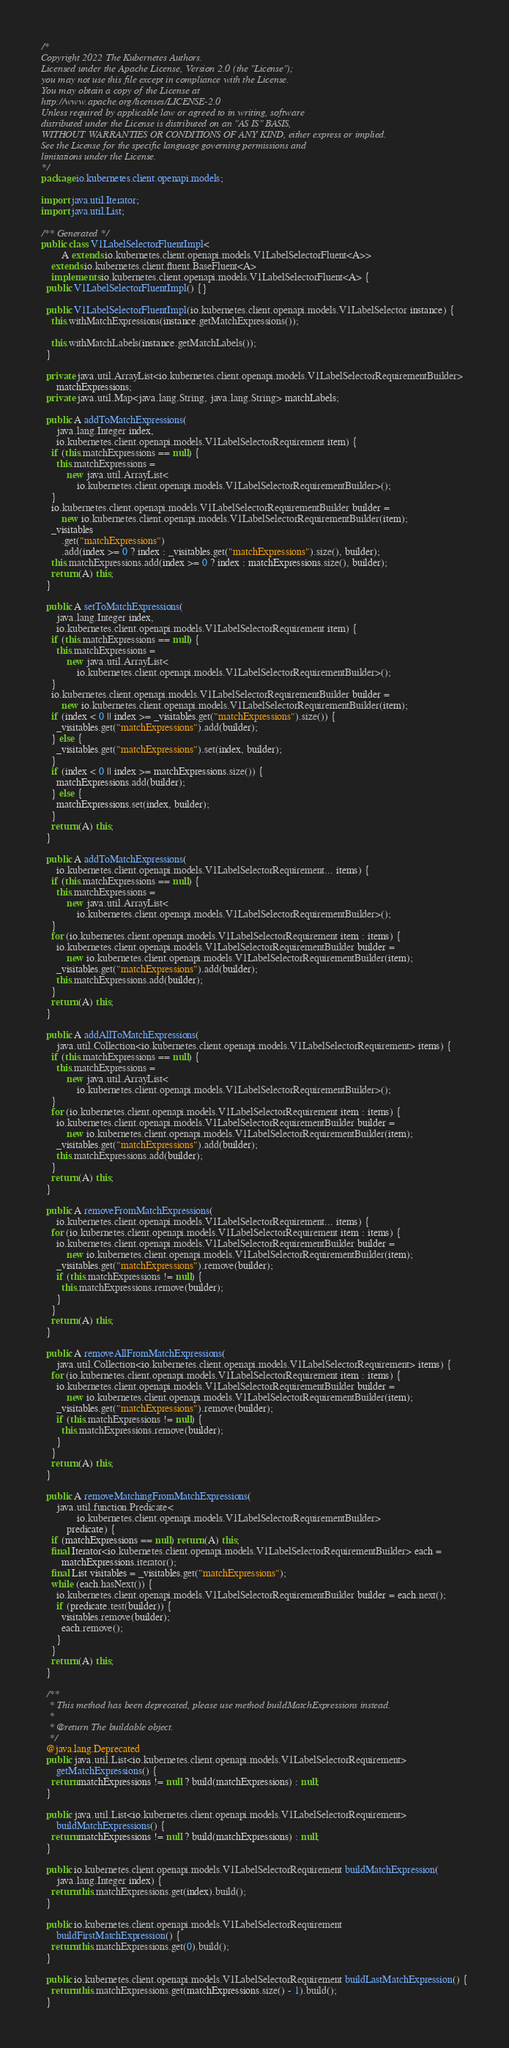Convert code to text. <code><loc_0><loc_0><loc_500><loc_500><_Java_>/*
Copyright 2022 The Kubernetes Authors.
Licensed under the Apache License, Version 2.0 (the "License");
you may not use this file except in compliance with the License.
You may obtain a copy of the License at
http://www.apache.org/licenses/LICENSE-2.0
Unless required by applicable law or agreed to in writing, software
distributed under the License is distributed on an "AS IS" BASIS,
WITHOUT WARRANTIES OR CONDITIONS OF ANY KIND, either express or implied.
See the License for the specific language governing permissions and
limitations under the License.
*/
package io.kubernetes.client.openapi.models;

import java.util.Iterator;
import java.util.List;

/** Generated */
public class V1LabelSelectorFluentImpl<
        A extends io.kubernetes.client.openapi.models.V1LabelSelectorFluent<A>>
    extends io.kubernetes.client.fluent.BaseFluent<A>
    implements io.kubernetes.client.openapi.models.V1LabelSelectorFluent<A> {
  public V1LabelSelectorFluentImpl() {}

  public V1LabelSelectorFluentImpl(io.kubernetes.client.openapi.models.V1LabelSelector instance) {
    this.withMatchExpressions(instance.getMatchExpressions());

    this.withMatchLabels(instance.getMatchLabels());
  }

  private java.util.ArrayList<io.kubernetes.client.openapi.models.V1LabelSelectorRequirementBuilder>
      matchExpressions;
  private java.util.Map<java.lang.String, java.lang.String> matchLabels;

  public A addToMatchExpressions(
      java.lang.Integer index,
      io.kubernetes.client.openapi.models.V1LabelSelectorRequirement item) {
    if (this.matchExpressions == null) {
      this.matchExpressions =
          new java.util.ArrayList<
              io.kubernetes.client.openapi.models.V1LabelSelectorRequirementBuilder>();
    }
    io.kubernetes.client.openapi.models.V1LabelSelectorRequirementBuilder builder =
        new io.kubernetes.client.openapi.models.V1LabelSelectorRequirementBuilder(item);
    _visitables
        .get("matchExpressions")
        .add(index >= 0 ? index : _visitables.get("matchExpressions").size(), builder);
    this.matchExpressions.add(index >= 0 ? index : matchExpressions.size(), builder);
    return (A) this;
  }

  public A setToMatchExpressions(
      java.lang.Integer index,
      io.kubernetes.client.openapi.models.V1LabelSelectorRequirement item) {
    if (this.matchExpressions == null) {
      this.matchExpressions =
          new java.util.ArrayList<
              io.kubernetes.client.openapi.models.V1LabelSelectorRequirementBuilder>();
    }
    io.kubernetes.client.openapi.models.V1LabelSelectorRequirementBuilder builder =
        new io.kubernetes.client.openapi.models.V1LabelSelectorRequirementBuilder(item);
    if (index < 0 || index >= _visitables.get("matchExpressions").size()) {
      _visitables.get("matchExpressions").add(builder);
    } else {
      _visitables.get("matchExpressions").set(index, builder);
    }
    if (index < 0 || index >= matchExpressions.size()) {
      matchExpressions.add(builder);
    } else {
      matchExpressions.set(index, builder);
    }
    return (A) this;
  }

  public A addToMatchExpressions(
      io.kubernetes.client.openapi.models.V1LabelSelectorRequirement... items) {
    if (this.matchExpressions == null) {
      this.matchExpressions =
          new java.util.ArrayList<
              io.kubernetes.client.openapi.models.V1LabelSelectorRequirementBuilder>();
    }
    for (io.kubernetes.client.openapi.models.V1LabelSelectorRequirement item : items) {
      io.kubernetes.client.openapi.models.V1LabelSelectorRequirementBuilder builder =
          new io.kubernetes.client.openapi.models.V1LabelSelectorRequirementBuilder(item);
      _visitables.get("matchExpressions").add(builder);
      this.matchExpressions.add(builder);
    }
    return (A) this;
  }

  public A addAllToMatchExpressions(
      java.util.Collection<io.kubernetes.client.openapi.models.V1LabelSelectorRequirement> items) {
    if (this.matchExpressions == null) {
      this.matchExpressions =
          new java.util.ArrayList<
              io.kubernetes.client.openapi.models.V1LabelSelectorRequirementBuilder>();
    }
    for (io.kubernetes.client.openapi.models.V1LabelSelectorRequirement item : items) {
      io.kubernetes.client.openapi.models.V1LabelSelectorRequirementBuilder builder =
          new io.kubernetes.client.openapi.models.V1LabelSelectorRequirementBuilder(item);
      _visitables.get("matchExpressions").add(builder);
      this.matchExpressions.add(builder);
    }
    return (A) this;
  }

  public A removeFromMatchExpressions(
      io.kubernetes.client.openapi.models.V1LabelSelectorRequirement... items) {
    for (io.kubernetes.client.openapi.models.V1LabelSelectorRequirement item : items) {
      io.kubernetes.client.openapi.models.V1LabelSelectorRequirementBuilder builder =
          new io.kubernetes.client.openapi.models.V1LabelSelectorRequirementBuilder(item);
      _visitables.get("matchExpressions").remove(builder);
      if (this.matchExpressions != null) {
        this.matchExpressions.remove(builder);
      }
    }
    return (A) this;
  }

  public A removeAllFromMatchExpressions(
      java.util.Collection<io.kubernetes.client.openapi.models.V1LabelSelectorRequirement> items) {
    for (io.kubernetes.client.openapi.models.V1LabelSelectorRequirement item : items) {
      io.kubernetes.client.openapi.models.V1LabelSelectorRequirementBuilder builder =
          new io.kubernetes.client.openapi.models.V1LabelSelectorRequirementBuilder(item);
      _visitables.get("matchExpressions").remove(builder);
      if (this.matchExpressions != null) {
        this.matchExpressions.remove(builder);
      }
    }
    return (A) this;
  }

  public A removeMatchingFromMatchExpressions(
      java.util.function.Predicate<
              io.kubernetes.client.openapi.models.V1LabelSelectorRequirementBuilder>
          predicate) {
    if (matchExpressions == null) return (A) this;
    final Iterator<io.kubernetes.client.openapi.models.V1LabelSelectorRequirementBuilder> each =
        matchExpressions.iterator();
    final List visitables = _visitables.get("matchExpressions");
    while (each.hasNext()) {
      io.kubernetes.client.openapi.models.V1LabelSelectorRequirementBuilder builder = each.next();
      if (predicate.test(builder)) {
        visitables.remove(builder);
        each.remove();
      }
    }
    return (A) this;
  }

  /**
   * This method has been deprecated, please use method buildMatchExpressions instead.
   *
   * @return The buildable object.
   */
  @java.lang.Deprecated
  public java.util.List<io.kubernetes.client.openapi.models.V1LabelSelectorRequirement>
      getMatchExpressions() {
    return matchExpressions != null ? build(matchExpressions) : null;
  }

  public java.util.List<io.kubernetes.client.openapi.models.V1LabelSelectorRequirement>
      buildMatchExpressions() {
    return matchExpressions != null ? build(matchExpressions) : null;
  }

  public io.kubernetes.client.openapi.models.V1LabelSelectorRequirement buildMatchExpression(
      java.lang.Integer index) {
    return this.matchExpressions.get(index).build();
  }

  public io.kubernetes.client.openapi.models.V1LabelSelectorRequirement
      buildFirstMatchExpression() {
    return this.matchExpressions.get(0).build();
  }

  public io.kubernetes.client.openapi.models.V1LabelSelectorRequirement buildLastMatchExpression() {
    return this.matchExpressions.get(matchExpressions.size() - 1).build();
  }
</code> 